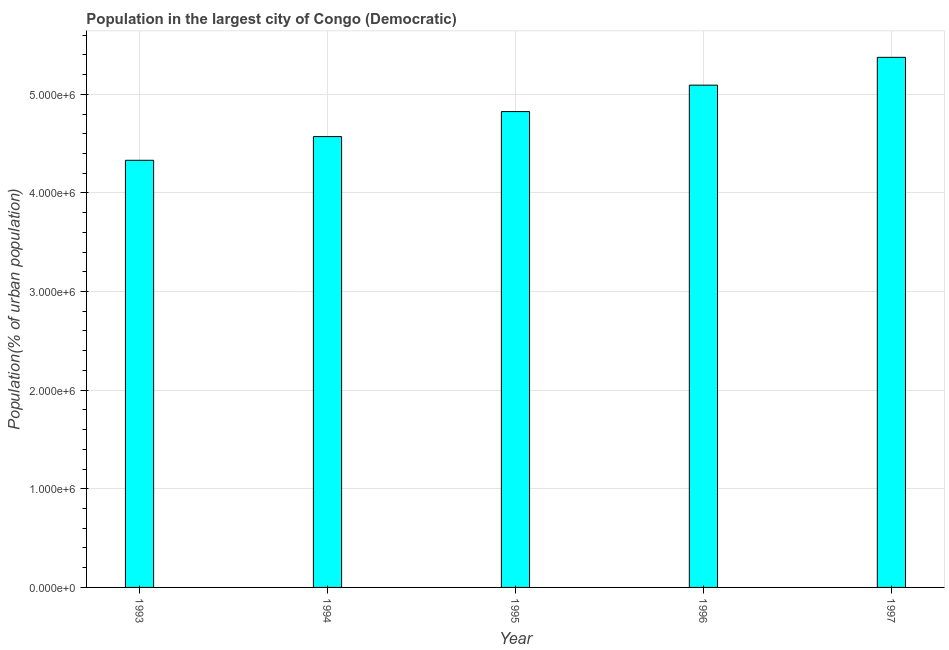What is the title of the graph?
Keep it short and to the point. Population in the largest city of Congo (Democratic). What is the label or title of the Y-axis?
Your answer should be very brief. Population(% of urban population). What is the population in largest city in 1994?
Give a very brief answer. 4.57e+06. Across all years, what is the maximum population in largest city?
Your response must be concise. 5.37e+06. Across all years, what is the minimum population in largest city?
Your answer should be very brief. 4.33e+06. In which year was the population in largest city maximum?
Provide a succinct answer. 1997. What is the sum of the population in largest city?
Provide a short and direct response. 2.42e+07. What is the difference between the population in largest city in 1994 and 1997?
Provide a succinct answer. -8.04e+05. What is the average population in largest city per year?
Make the answer very short. 4.84e+06. What is the median population in largest city?
Provide a short and direct response. 4.82e+06. What is the ratio of the population in largest city in 1993 to that in 1997?
Offer a terse response. 0.81. Is the population in largest city in 1994 less than that in 1996?
Offer a very short reply. Yes. What is the difference between the highest and the second highest population in largest city?
Offer a terse response. 2.82e+05. Is the sum of the population in largest city in 1994 and 1996 greater than the maximum population in largest city across all years?
Keep it short and to the point. Yes. What is the difference between the highest and the lowest population in largest city?
Provide a short and direct response. 1.04e+06. In how many years, is the population in largest city greater than the average population in largest city taken over all years?
Provide a short and direct response. 2. How many years are there in the graph?
Ensure brevity in your answer.  5. What is the difference between two consecutive major ticks on the Y-axis?
Keep it short and to the point. 1.00e+06. Are the values on the major ticks of Y-axis written in scientific E-notation?
Offer a very short reply. Yes. What is the Population(% of urban population) of 1993?
Give a very brief answer. 4.33e+06. What is the Population(% of urban population) in 1994?
Your response must be concise. 4.57e+06. What is the Population(% of urban population) in 1995?
Offer a very short reply. 4.82e+06. What is the Population(% of urban population) in 1996?
Give a very brief answer. 5.09e+06. What is the Population(% of urban population) in 1997?
Your answer should be compact. 5.37e+06. What is the difference between the Population(% of urban population) in 1993 and 1994?
Your response must be concise. -2.40e+05. What is the difference between the Population(% of urban population) in 1993 and 1995?
Offer a very short reply. -4.94e+05. What is the difference between the Population(% of urban population) in 1993 and 1996?
Keep it short and to the point. -7.62e+05. What is the difference between the Population(% of urban population) in 1993 and 1997?
Your answer should be very brief. -1.04e+06. What is the difference between the Population(% of urban population) in 1994 and 1995?
Ensure brevity in your answer.  -2.54e+05. What is the difference between the Population(% of urban population) in 1994 and 1996?
Offer a terse response. -5.22e+05. What is the difference between the Population(% of urban population) in 1994 and 1997?
Your response must be concise. -8.04e+05. What is the difference between the Population(% of urban population) in 1995 and 1996?
Keep it short and to the point. -2.68e+05. What is the difference between the Population(% of urban population) in 1995 and 1997?
Keep it short and to the point. -5.50e+05. What is the difference between the Population(% of urban population) in 1996 and 1997?
Offer a terse response. -2.82e+05. What is the ratio of the Population(% of urban population) in 1993 to that in 1994?
Offer a terse response. 0.95. What is the ratio of the Population(% of urban population) in 1993 to that in 1995?
Provide a succinct answer. 0.9. What is the ratio of the Population(% of urban population) in 1993 to that in 1996?
Your answer should be very brief. 0.85. What is the ratio of the Population(% of urban population) in 1993 to that in 1997?
Your answer should be very brief. 0.81. What is the ratio of the Population(% of urban population) in 1994 to that in 1995?
Offer a very short reply. 0.95. What is the ratio of the Population(% of urban population) in 1994 to that in 1996?
Your answer should be compact. 0.9. What is the ratio of the Population(% of urban population) in 1994 to that in 1997?
Keep it short and to the point. 0.85. What is the ratio of the Population(% of urban population) in 1995 to that in 1996?
Keep it short and to the point. 0.95. What is the ratio of the Population(% of urban population) in 1995 to that in 1997?
Your answer should be compact. 0.9. What is the ratio of the Population(% of urban population) in 1996 to that in 1997?
Offer a terse response. 0.95. 